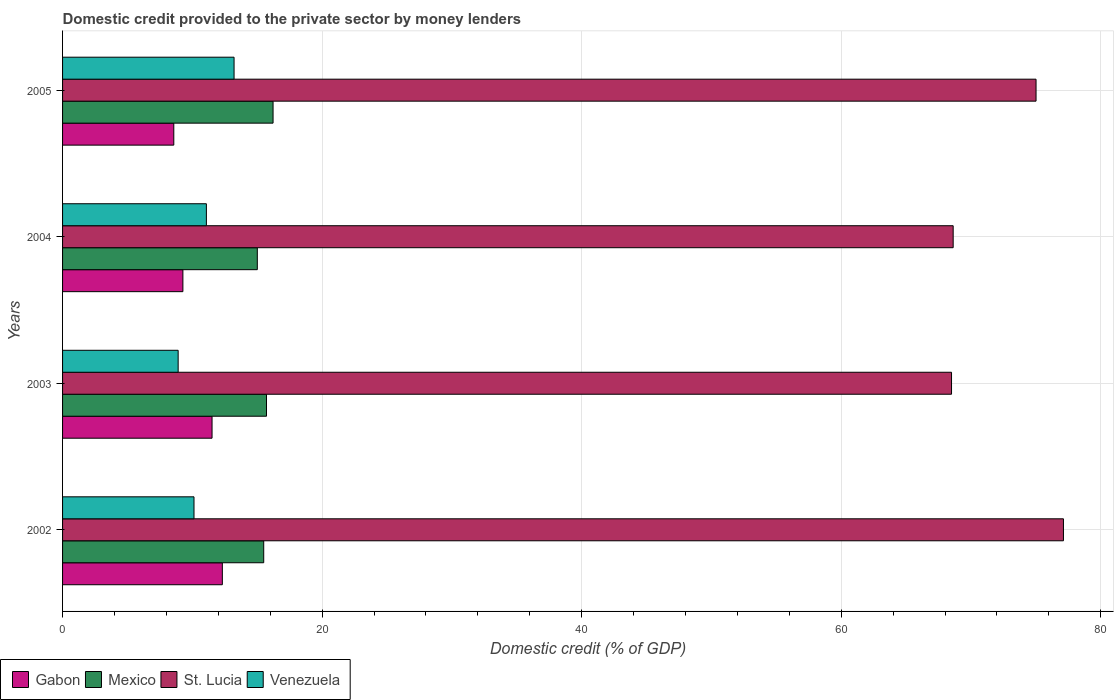How many groups of bars are there?
Make the answer very short. 4. Are the number of bars per tick equal to the number of legend labels?
Provide a short and direct response. Yes. How many bars are there on the 3rd tick from the top?
Your answer should be compact. 4. How many bars are there on the 4th tick from the bottom?
Make the answer very short. 4. What is the domestic credit provided to the private sector by money lenders in Gabon in 2004?
Make the answer very short. 9.27. Across all years, what is the maximum domestic credit provided to the private sector by money lenders in Gabon?
Your response must be concise. 12.31. Across all years, what is the minimum domestic credit provided to the private sector by money lenders in St. Lucia?
Your answer should be very brief. 68.5. In which year was the domestic credit provided to the private sector by money lenders in St. Lucia minimum?
Make the answer very short. 2003. What is the total domestic credit provided to the private sector by money lenders in Venezuela in the graph?
Offer a terse response. 43.33. What is the difference between the domestic credit provided to the private sector by money lenders in St. Lucia in 2004 and that in 2005?
Give a very brief answer. -6.38. What is the difference between the domestic credit provided to the private sector by money lenders in St. Lucia in 2004 and the domestic credit provided to the private sector by money lenders in Gabon in 2003?
Provide a succinct answer. 57.11. What is the average domestic credit provided to the private sector by money lenders in St. Lucia per year?
Offer a very short reply. 72.31. In the year 2005, what is the difference between the domestic credit provided to the private sector by money lenders in Venezuela and domestic credit provided to the private sector by money lenders in Mexico?
Keep it short and to the point. -3. In how many years, is the domestic credit provided to the private sector by money lenders in Venezuela greater than 52 %?
Provide a succinct answer. 0. What is the ratio of the domestic credit provided to the private sector by money lenders in St. Lucia in 2002 to that in 2004?
Give a very brief answer. 1.12. What is the difference between the highest and the second highest domestic credit provided to the private sector by money lenders in Gabon?
Keep it short and to the point. 0.79. What is the difference between the highest and the lowest domestic credit provided to the private sector by money lenders in St. Lucia?
Give a very brief answer. 8.62. Is the sum of the domestic credit provided to the private sector by money lenders in Venezuela in 2002 and 2005 greater than the maximum domestic credit provided to the private sector by money lenders in St. Lucia across all years?
Give a very brief answer. No. What does the 1st bar from the top in 2002 represents?
Keep it short and to the point. Venezuela. What does the 3rd bar from the bottom in 2004 represents?
Your answer should be compact. St. Lucia. Is it the case that in every year, the sum of the domestic credit provided to the private sector by money lenders in St. Lucia and domestic credit provided to the private sector by money lenders in Mexico is greater than the domestic credit provided to the private sector by money lenders in Venezuela?
Make the answer very short. Yes. How many years are there in the graph?
Provide a short and direct response. 4. Does the graph contain grids?
Your answer should be very brief. Yes. What is the title of the graph?
Offer a very short reply. Domestic credit provided to the private sector by money lenders. What is the label or title of the X-axis?
Your response must be concise. Domestic credit (% of GDP). What is the label or title of the Y-axis?
Ensure brevity in your answer.  Years. What is the Domestic credit (% of GDP) of Gabon in 2002?
Your answer should be very brief. 12.31. What is the Domestic credit (% of GDP) in Mexico in 2002?
Your answer should be very brief. 15.5. What is the Domestic credit (% of GDP) in St. Lucia in 2002?
Ensure brevity in your answer.  77.12. What is the Domestic credit (% of GDP) of Venezuela in 2002?
Your answer should be very brief. 10.13. What is the Domestic credit (% of GDP) in Gabon in 2003?
Make the answer very short. 11.52. What is the Domestic credit (% of GDP) of Mexico in 2003?
Provide a short and direct response. 15.71. What is the Domestic credit (% of GDP) of St. Lucia in 2003?
Your response must be concise. 68.5. What is the Domestic credit (% of GDP) of Venezuela in 2003?
Provide a short and direct response. 8.91. What is the Domestic credit (% of GDP) in Gabon in 2004?
Offer a terse response. 9.27. What is the Domestic credit (% of GDP) in Mexico in 2004?
Provide a succinct answer. 15.01. What is the Domestic credit (% of GDP) in St. Lucia in 2004?
Offer a terse response. 68.62. What is the Domestic credit (% of GDP) of Venezuela in 2004?
Keep it short and to the point. 11.08. What is the Domestic credit (% of GDP) in Gabon in 2005?
Give a very brief answer. 8.57. What is the Domestic credit (% of GDP) in Mexico in 2005?
Provide a short and direct response. 16.22. What is the Domestic credit (% of GDP) of St. Lucia in 2005?
Keep it short and to the point. 75.01. What is the Domestic credit (% of GDP) of Venezuela in 2005?
Your answer should be very brief. 13.21. Across all years, what is the maximum Domestic credit (% of GDP) in Gabon?
Provide a succinct answer. 12.31. Across all years, what is the maximum Domestic credit (% of GDP) of Mexico?
Your answer should be compact. 16.22. Across all years, what is the maximum Domestic credit (% of GDP) in St. Lucia?
Keep it short and to the point. 77.12. Across all years, what is the maximum Domestic credit (% of GDP) of Venezuela?
Your answer should be very brief. 13.21. Across all years, what is the minimum Domestic credit (% of GDP) of Gabon?
Keep it short and to the point. 8.57. Across all years, what is the minimum Domestic credit (% of GDP) in Mexico?
Offer a terse response. 15.01. Across all years, what is the minimum Domestic credit (% of GDP) in St. Lucia?
Ensure brevity in your answer.  68.5. Across all years, what is the minimum Domestic credit (% of GDP) in Venezuela?
Keep it short and to the point. 8.91. What is the total Domestic credit (% of GDP) of Gabon in the graph?
Ensure brevity in your answer.  41.67. What is the total Domestic credit (% of GDP) in Mexico in the graph?
Keep it short and to the point. 62.44. What is the total Domestic credit (% of GDP) in St. Lucia in the graph?
Offer a very short reply. 289.25. What is the total Domestic credit (% of GDP) of Venezuela in the graph?
Provide a succinct answer. 43.33. What is the difference between the Domestic credit (% of GDP) in Gabon in 2002 and that in 2003?
Make the answer very short. 0.79. What is the difference between the Domestic credit (% of GDP) in Mexico in 2002 and that in 2003?
Provide a short and direct response. -0.21. What is the difference between the Domestic credit (% of GDP) in St. Lucia in 2002 and that in 2003?
Offer a terse response. 8.62. What is the difference between the Domestic credit (% of GDP) in Venezuela in 2002 and that in 2003?
Ensure brevity in your answer.  1.22. What is the difference between the Domestic credit (% of GDP) of Gabon in 2002 and that in 2004?
Offer a terse response. 3.04. What is the difference between the Domestic credit (% of GDP) in Mexico in 2002 and that in 2004?
Offer a terse response. 0.49. What is the difference between the Domestic credit (% of GDP) of St. Lucia in 2002 and that in 2004?
Give a very brief answer. 8.5. What is the difference between the Domestic credit (% of GDP) of Venezuela in 2002 and that in 2004?
Provide a short and direct response. -0.95. What is the difference between the Domestic credit (% of GDP) in Gabon in 2002 and that in 2005?
Offer a terse response. 3.74. What is the difference between the Domestic credit (% of GDP) of Mexico in 2002 and that in 2005?
Offer a very short reply. -0.72. What is the difference between the Domestic credit (% of GDP) in St. Lucia in 2002 and that in 2005?
Ensure brevity in your answer.  2.11. What is the difference between the Domestic credit (% of GDP) in Venezuela in 2002 and that in 2005?
Keep it short and to the point. -3.09. What is the difference between the Domestic credit (% of GDP) of Gabon in 2003 and that in 2004?
Your answer should be very brief. 2.25. What is the difference between the Domestic credit (% of GDP) in Mexico in 2003 and that in 2004?
Offer a terse response. 0.71. What is the difference between the Domestic credit (% of GDP) in St. Lucia in 2003 and that in 2004?
Keep it short and to the point. -0.13. What is the difference between the Domestic credit (% of GDP) of Venezuela in 2003 and that in 2004?
Keep it short and to the point. -2.18. What is the difference between the Domestic credit (% of GDP) of Gabon in 2003 and that in 2005?
Ensure brevity in your answer.  2.95. What is the difference between the Domestic credit (% of GDP) in Mexico in 2003 and that in 2005?
Your answer should be compact. -0.5. What is the difference between the Domestic credit (% of GDP) of St. Lucia in 2003 and that in 2005?
Your answer should be very brief. -6.51. What is the difference between the Domestic credit (% of GDP) in Venezuela in 2003 and that in 2005?
Your answer should be compact. -4.31. What is the difference between the Domestic credit (% of GDP) of Gabon in 2004 and that in 2005?
Keep it short and to the point. 0.7. What is the difference between the Domestic credit (% of GDP) of Mexico in 2004 and that in 2005?
Offer a very short reply. -1.21. What is the difference between the Domestic credit (% of GDP) of St. Lucia in 2004 and that in 2005?
Your response must be concise. -6.38. What is the difference between the Domestic credit (% of GDP) of Venezuela in 2004 and that in 2005?
Provide a short and direct response. -2.13. What is the difference between the Domestic credit (% of GDP) in Gabon in 2002 and the Domestic credit (% of GDP) in Mexico in 2003?
Your response must be concise. -3.4. What is the difference between the Domestic credit (% of GDP) in Gabon in 2002 and the Domestic credit (% of GDP) in St. Lucia in 2003?
Your answer should be very brief. -56.19. What is the difference between the Domestic credit (% of GDP) in Gabon in 2002 and the Domestic credit (% of GDP) in Venezuela in 2003?
Provide a succinct answer. 3.4. What is the difference between the Domestic credit (% of GDP) in Mexico in 2002 and the Domestic credit (% of GDP) in St. Lucia in 2003?
Ensure brevity in your answer.  -53. What is the difference between the Domestic credit (% of GDP) in Mexico in 2002 and the Domestic credit (% of GDP) in Venezuela in 2003?
Make the answer very short. 6.59. What is the difference between the Domestic credit (% of GDP) in St. Lucia in 2002 and the Domestic credit (% of GDP) in Venezuela in 2003?
Provide a short and direct response. 68.21. What is the difference between the Domestic credit (% of GDP) of Gabon in 2002 and the Domestic credit (% of GDP) of Mexico in 2004?
Ensure brevity in your answer.  -2.7. What is the difference between the Domestic credit (% of GDP) in Gabon in 2002 and the Domestic credit (% of GDP) in St. Lucia in 2004?
Your answer should be very brief. -56.31. What is the difference between the Domestic credit (% of GDP) of Gabon in 2002 and the Domestic credit (% of GDP) of Venezuela in 2004?
Your response must be concise. 1.23. What is the difference between the Domestic credit (% of GDP) in Mexico in 2002 and the Domestic credit (% of GDP) in St. Lucia in 2004?
Give a very brief answer. -53.12. What is the difference between the Domestic credit (% of GDP) in Mexico in 2002 and the Domestic credit (% of GDP) in Venezuela in 2004?
Give a very brief answer. 4.42. What is the difference between the Domestic credit (% of GDP) of St. Lucia in 2002 and the Domestic credit (% of GDP) of Venezuela in 2004?
Provide a succinct answer. 66.04. What is the difference between the Domestic credit (% of GDP) in Gabon in 2002 and the Domestic credit (% of GDP) in Mexico in 2005?
Ensure brevity in your answer.  -3.91. What is the difference between the Domestic credit (% of GDP) of Gabon in 2002 and the Domestic credit (% of GDP) of St. Lucia in 2005?
Your answer should be very brief. -62.7. What is the difference between the Domestic credit (% of GDP) of Gabon in 2002 and the Domestic credit (% of GDP) of Venezuela in 2005?
Give a very brief answer. -0.9. What is the difference between the Domestic credit (% of GDP) of Mexico in 2002 and the Domestic credit (% of GDP) of St. Lucia in 2005?
Your answer should be very brief. -59.51. What is the difference between the Domestic credit (% of GDP) in Mexico in 2002 and the Domestic credit (% of GDP) in Venezuela in 2005?
Keep it short and to the point. 2.28. What is the difference between the Domestic credit (% of GDP) in St. Lucia in 2002 and the Domestic credit (% of GDP) in Venezuela in 2005?
Ensure brevity in your answer.  63.91. What is the difference between the Domestic credit (% of GDP) of Gabon in 2003 and the Domestic credit (% of GDP) of Mexico in 2004?
Ensure brevity in your answer.  -3.49. What is the difference between the Domestic credit (% of GDP) in Gabon in 2003 and the Domestic credit (% of GDP) in St. Lucia in 2004?
Your answer should be very brief. -57.11. What is the difference between the Domestic credit (% of GDP) in Gabon in 2003 and the Domestic credit (% of GDP) in Venezuela in 2004?
Provide a succinct answer. 0.44. What is the difference between the Domestic credit (% of GDP) of Mexico in 2003 and the Domestic credit (% of GDP) of St. Lucia in 2004?
Your answer should be compact. -52.91. What is the difference between the Domestic credit (% of GDP) in Mexico in 2003 and the Domestic credit (% of GDP) in Venezuela in 2004?
Offer a very short reply. 4.63. What is the difference between the Domestic credit (% of GDP) in St. Lucia in 2003 and the Domestic credit (% of GDP) in Venezuela in 2004?
Offer a terse response. 57.42. What is the difference between the Domestic credit (% of GDP) in Gabon in 2003 and the Domestic credit (% of GDP) in Mexico in 2005?
Provide a short and direct response. -4.7. What is the difference between the Domestic credit (% of GDP) in Gabon in 2003 and the Domestic credit (% of GDP) in St. Lucia in 2005?
Offer a very short reply. -63.49. What is the difference between the Domestic credit (% of GDP) of Gabon in 2003 and the Domestic credit (% of GDP) of Venezuela in 2005?
Keep it short and to the point. -1.7. What is the difference between the Domestic credit (% of GDP) in Mexico in 2003 and the Domestic credit (% of GDP) in St. Lucia in 2005?
Offer a terse response. -59.3. What is the difference between the Domestic credit (% of GDP) of Mexico in 2003 and the Domestic credit (% of GDP) of Venezuela in 2005?
Ensure brevity in your answer.  2.5. What is the difference between the Domestic credit (% of GDP) in St. Lucia in 2003 and the Domestic credit (% of GDP) in Venezuela in 2005?
Your response must be concise. 55.28. What is the difference between the Domestic credit (% of GDP) of Gabon in 2004 and the Domestic credit (% of GDP) of Mexico in 2005?
Your answer should be very brief. -6.95. What is the difference between the Domestic credit (% of GDP) of Gabon in 2004 and the Domestic credit (% of GDP) of St. Lucia in 2005?
Your answer should be compact. -65.74. What is the difference between the Domestic credit (% of GDP) of Gabon in 2004 and the Domestic credit (% of GDP) of Venezuela in 2005?
Give a very brief answer. -3.94. What is the difference between the Domestic credit (% of GDP) in Mexico in 2004 and the Domestic credit (% of GDP) in St. Lucia in 2005?
Your answer should be compact. -60. What is the difference between the Domestic credit (% of GDP) in Mexico in 2004 and the Domestic credit (% of GDP) in Venezuela in 2005?
Provide a succinct answer. 1.79. What is the difference between the Domestic credit (% of GDP) in St. Lucia in 2004 and the Domestic credit (% of GDP) in Venezuela in 2005?
Offer a terse response. 55.41. What is the average Domestic credit (% of GDP) of Gabon per year?
Your answer should be compact. 10.42. What is the average Domestic credit (% of GDP) in Mexico per year?
Your answer should be very brief. 15.61. What is the average Domestic credit (% of GDP) of St. Lucia per year?
Ensure brevity in your answer.  72.31. What is the average Domestic credit (% of GDP) in Venezuela per year?
Offer a very short reply. 10.83. In the year 2002, what is the difference between the Domestic credit (% of GDP) in Gabon and Domestic credit (% of GDP) in Mexico?
Keep it short and to the point. -3.19. In the year 2002, what is the difference between the Domestic credit (% of GDP) in Gabon and Domestic credit (% of GDP) in St. Lucia?
Offer a very short reply. -64.81. In the year 2002, what is the difference between the Domestic credit (% of GDP) of Gabon and Domestic credit (% of GDP) of Venezuela?
Your answer should be compact. 2.18. In the year 2002, what is the difference between the Domestic credit (% of GDP) in Mexico and Domestic credit (% of GDP) in St. Lucia?
Your response must be concise. -61.62. In the year 2002, what is the difference between the Domestic credit (% of GDP) in Mexico and Domestic credit (% of GDP) in Venezuela?
Your answer should be very brief. 5.37. In the year 2002, what is the difference between the Domestic credit (% of GDP) of St. Lucia and Domestic credit (% of GDP) of Venezuela?
Provide a succinct answer. 66.99. In the year 2003, what is the difference between the Domestic credit (% of GDP) of Gabon and Domestic credit (% of GDP) of Mexico?
Provide a succinct answer. -4.2. In the year 2003, what is the difference between the Domestic credit (% of GDP) in Gabon and Domestic credit (% of GDP) in St. Lucia?
Offer a very short reply. -56.98. In the year 2003, what is the difference between the Domestic credit (% of GDP) in Gabon and Domestic credit (% of GDP) in Venezuela?
Provide a succinct answer. 2.61. In the year 2003, what is the difference between the Domestic credit (% of GDP) of Mexico and Domestic credit (% of GDP) of St. Lucia?
Ensure brevity in your answer.  -52.78. In the year 2003, what is the difference between the Domestic credit (% of GDP) in Mexico and Domestic credit (% of GDP) in Venezuela?
Your answer should be compact. 6.81. In the year 2003, what is the difference between the Domestic credit (% of GDP) in St. Lucia and Domestic credit (% of GDP) in Venezuela?
Provide a short and direct response. 59.59. In the year 2004, what is the difference between the Domestic credit (% of GDP) in Gabon and Domestic credit (% of GDP) in Mexico?
Offer a terse response. -5.74. In the year 2004, what is the difference between the Domestic credit (% of GDP) of Gabon and Domestic credit (% of GDP) of St. Lucia?
Provide a short and direct response. -59.35. In the year 2004, what is the difference between the Domestic credit (% of GDP) of Gabon and Domestic credit (% of GDP) of Venezuela?
Your response must be concise. -1.81. In the year 2004, what is the difference between the Domestic credit (% of GDP) of Mexico and Domestic credit (% of GDP) of St. Lucia?
Offer a terse response. -53.62. In the year 2004, what is the difference between the Domestic credit (% of GDP) of Mexico and Domestic credit (% of GDP) of Venezuela?
Offer a very short reply. 3.92. In the year 2004, what is the difference between the Domestic credit (% of GDP) of St. Lucia and Domestic credit (% of GDP) of Venezuela?
Your answer should be compact. 57.54. In the year 2005, what is the difference between the Domestic credit (% of GDP) in Gabon and Domestic credit (% of GDP) in Mexico?
Ensure brevity in your answer.  -7.65. In the year 2005, what is the difference between the Domestic credit (% of GDP) of Gabon and Domestic credit (% of GDP) of St. Lucia?
Provide a succinct answer. -66.44. In the year 2005, what is the difference between the Domestic credit (% of GDP) in Gabon and Domestic credit (% of GDP) in Venezuela?
Provide a short and direct response. -4.64. In the year 2005, what is the difference between the Domestic credit (% of GDP) in Mexico and Domestic credit (% of GDP) in St. Lucia?
Your answer should be very brief. -58.79. In the year 2005, what is the difference between the Domestic credit (% of GDP) of Mexico and Domestic credit (% of GDP) of Venezuela?
Give a very brief answer. 3. In the year 2005, what is the difference between the Domestic credit (% of GDP) of St. Lucia and Domestic credit (% of GDP) of Venezuela?
Provide a short and direct response. 61.79. What is the ratio of the Domestic credit (% of GDP) of Gabon in 2002 to that in 2003?
Provide a short and direct response. 1.07. What is the ratio of the Domestic credit (% of GDP) of Mexico in 2002 to that in 2003?
Provide a succinct answer. 0.99. What is the ratio of the Domestic credit (% of GDP) of St. Lucia in 2002 to that in 2003?
Provide a succinct answer. 1.13. What is the ratio of the Domestic credit (% of GDP) of Venezuela in 2002 to that in 2003?
Keep it short and to the point. 1.14. What is the ratio of the Domestic credit (% of GDP) in Gabon in 2002 to that in 2004?
Make the answer very short. 1.33. What is the ratio of the Domestic credit (% of GDP) in Mexico in 2002 to that in 2004?
Your response must be concise. 1.03. What is the ratio of the Domestic credit (% of GDP) in St. Lucia in 2002 to that in 2004?
Your response must be concise. 1.12. What is the ratio of the Domestic credit (% of GDP) of Venezuela in 2002 to that in 2004?
Your answer should be compact. 0.91. What is the ratio of the Domestic credit (% of GDP) in Gabon in 2002 to that in 2005?
Ensure brevity in your answer.  1.44. What is the ratio of the Domestic credit (% of GDP) in Mexico in 2002 to that in 2005?
Your answer should be very brief. 0.96. What is the ratio of the Domestic credit (% of GDP) in St. Lucia in 2002 to that in 2005?
Offer a very short reply. 1.03. What is the ratio of the Domestic credit (% of GDP) of Venezuela in 2002 to that in 2005?
Offer a very short reply. 0.77. What is the ratio of the Domestic credit (% of GDP) in Gabon in 2003 to that in 2004?
Ensure brevity in your answer.  1.24. What is the ratio of the Domestic credit (% of GDP) of Mexico in 2003 to that in 2004?
Keep it short and to the point. 1.05. What is the ratio of the Domestic credit (% of GDP) in St. Lucia in 2003 to that in 2004?
Your answer should be compact. 1. What is the ratio of the Domestic credit (% of GDP) in Venezuela in 2003 to that in 2004?
Provide a short and direct response. 0.8. What is the ratio of the Domestic credit (% of GDP) of Gabon in 2003 to that in 2005?
Offer a terse response. 1.34. What is the ratio of the Domestic credit (% of GDP) in Mexico in 2003 to that in 2005?
Make the answer very short. 0.97. What is the ratio of the Domestic credit (% of GDP) in St. Lucia in 2003 to that in 2005?
Your answer should be compact. 0.91. What is the ratio of the Domestic credit (% of GDP) of Venezuela in 2003 to that in 2005?
Offer a terse response. 0.67. What is the ratio of the Domestic credit (% of GDP) in Gabon in 2004 to that in 2005?
Your answer should be compact. 1.08. What is the ratio of the Domestic credit (% of GDP) of Mexico in 2004 to that in 2005?
Keep it short and to the point. 0.93. What is the ratio of the Domestic credit (% of GDP) in St. Lucia in 2004 to that in 2005?
Offer a very short reply. 0.91. What is the ratio of the Domestic credit (% of GDP) in Venezuela in 2004 to that in 2005?
Provide a short and direct response. 0.84. What is the difference between the highest and the second highest Domestic credit (% of GDP) in Gabon?
Your answer should be compact. 0.79. What is the difference between the highest and the second highest Domestic credit (% of GDP) in Mexico?
Your answer should be very brief. 0.5. What is the difference between the highest and the second highest Domestic credit (% of GDP) in St. Lucia?
Give a very brief answer. 2.11. What is the difference between the highest and the second highest Domestic credit (% of GDP) of Venezuela?
Give a very brief answer. 2.13. What is the difference between the highest and the lowest Domestic credit (% of GDP) of Gabon?
Give a very brief answer. 3.74. What is the difference between the highest and the lowest Domestic credit (% of GDP) of Mexico?
Your answer should be compact. 1.21. What is the difference between the highest and the lowest Domestic credit (% of GDP) in St. Lucia?
Provide a succinct answer. 8.62. What is the difference between the highest and the lowest Domestic credit (% of GDP) of Venezuela?
Provide a succinct answer. 4.31. 